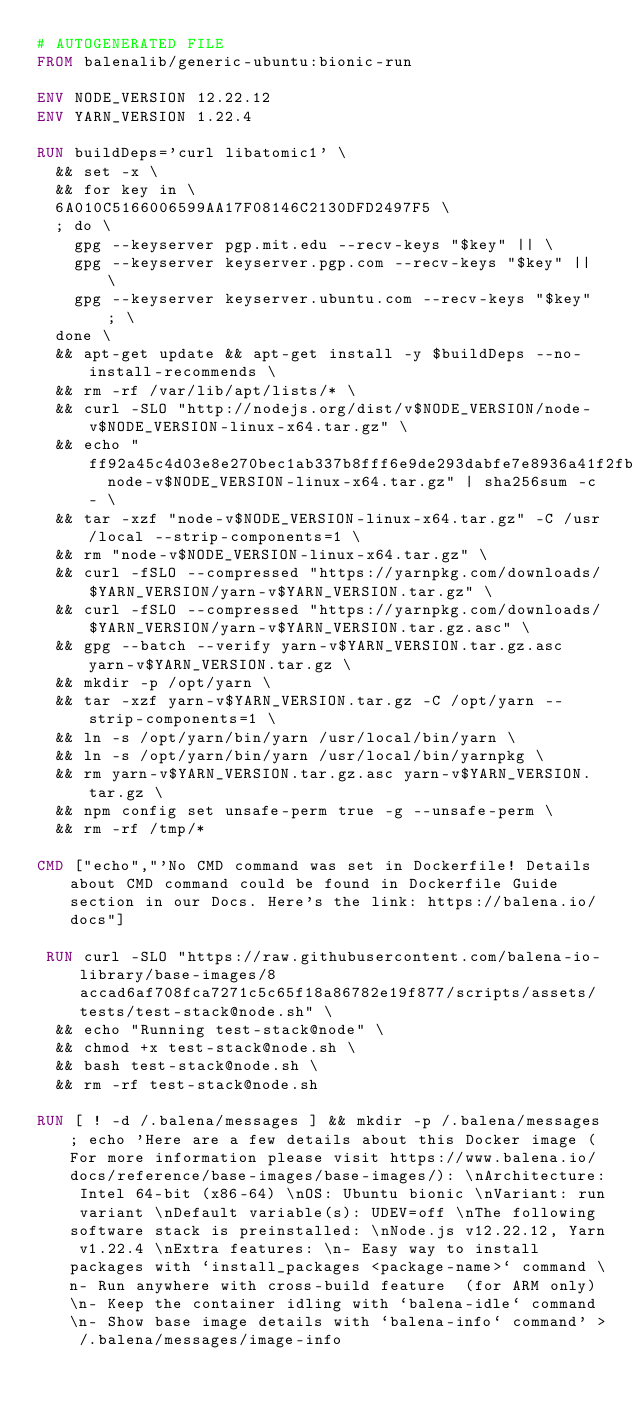Convert code to text. <code><loc_0><loc_0><loc_500><loc_500><_Dockerfile_># AUTOGENERATED FILE
FROM balenalib/generic-ubuntu:bionic-run

ENV NODE_VERSION 12.22.12
ENV YARN_VERSION 1.22.4

RUN buildDeps='curl libatomic1' \
	&& set -x \
	&& for key in \
	6A010C5166006599AA17F08146C2130DFD2497F5 \
	; do \
		gpg --keyserver pgp.mit.edu --recv-keys "$key" || \
		gpg --keyserver keyserver.pgp.com --recv-keys "$key" || \
		gpg --keyserver keyserver.ubuntu.com --recv-keys "$key" ; \
	done \
	&& apt-get update && apt-get install -y $buildDeps --no-install-recommends \
	&& rm -rf /var/lib/apt/lists/* \
	&& curl -SLO "http://nodejs.org/dist/v$NODE_VERSION/node-v$NODE_VERSION-linux-x64.tar.gz" \
	&& echo "ff92a45c4d03e8e270bec1ab337b8fff6e9de293dabfe7e8936a41f2fb0b202e  node-v$NODE_VERSION-linux-x64.tar.gz" | sha256sum -c - \
	&& tar -xzf "node-v$NODE_VERSION-linux-x64.tar.gz" -C /usr/local --strip-components=1 \
	&& rm "node-v$NODE_VERSION-linux-x64.tar.gz" \
	&& curl -fSLO --compressed "https://yarnpkg.com/downloads/$YARN_VERSION/yarn-v$YARN_VERSION.tar.gz" \
	&& curl -fSLO --compressed "https://yarnpkg.com/downloads/$YARN_VERSION/yarn-v$YARN_VERSION.tar.gz.asc" \
	&& gpg --batch --verify yarn-v$YARN_VERSION.tar.gz.asc yarn-v$YARN_VERSION.tar.gz \
	&& mkdir -p /opt/yarn \
	&& tar -xzf yarn-v$YARN_VERSION.tar.gz -C /opt/yarn --strip-components=1 \
	&& ln -s /opt/yarn/bin/yarn /usr/local/bin/yarn \
	&& ln -s /opt/yarn/bin/yarn /usr/local/bin/yarnpkg \
	&& rm yarn-v$YARN_VERSION.tar.gz.asc yarn-v$YARN_VERSION.tar.gz \
	&& npm config set unsafe-perm true -g --unsafe-perm \
	&& rm -rf /tmp/*

CMD ["echo","'No CMD command was set in Dockerfile! Details about CMD command could be found in Dockerfile Guide section in our Docs. Here's the link: https://balena.io/docs"]

 RUN curl -SLO "https://raw.githubusercontent.com/balena-io-library/base-images/8accad6af708fca7271c5c65f18a86782e19f877/scripts/assets/tests/test-stack@node.sh" \
  && echo "Running test-stack@node" \
  && chmod +x test-stack@node.sh \
  && bash test-stack@node.sh \
  && rm -rf test-stack@node.sh 

RUN [ ! -d /.balena/messages ] && mkdir -p /.balena/messages; echo 'Here are a few details about this Docker image (For more information please visit https://www.balena.io/docs/reference/base-images/base-images/): \nArchitecture: Intel 64-bit (x86-64) \nOS: Ubuntu bionic \nVariant: run variant \nDefault variable(s): UDEV=off \nThe following software stack is preinstalled: \nNode.js v12.22.12, Yarn v1.22.4 \nExtra features: \n- Easy way to install packages with `install_packages <package-name>` command \n- Run anywhere with cross-build feature  (for ARM only) \n- Keep the container idling with `balena-idle` command \n- Show base image details with `balena-info` command' > /.balena/messages/image-info</code> 